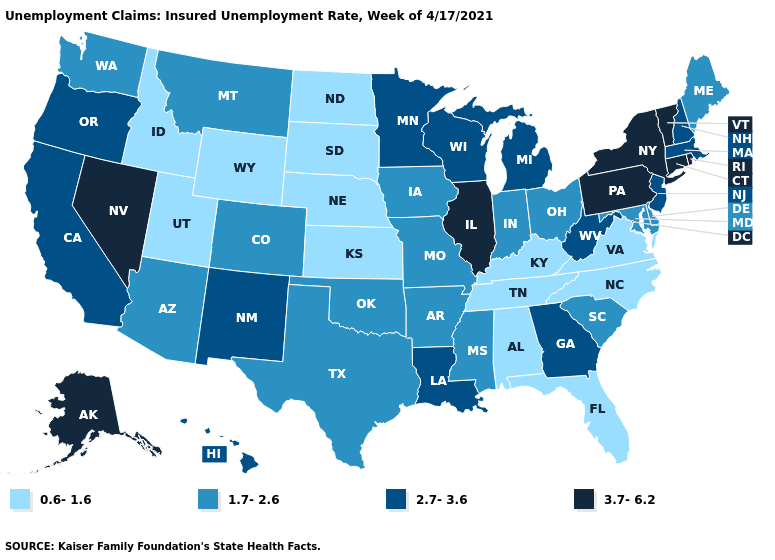Among the states that border Wisconsin , does Minnesota have the lowest value?
Be succinct. No. Name the states that have a value in the range 3.7-6.2?
Quick response, please. Alaska, Connecticut, Illinois, Nevada, New York, Pennsylvania, Rhode Island, Vermont. Name the states that have a value in the range 2.7-3.6?
Answer briefly. California, Georgia, Hawaii, Louisiana, Massachusetts, Michigan, Minnesota, New Hampshire, New Jersey, New Mexico, Oregon, West Virginia, Wisconsin. What is the value of West Virginia?
Short answer required. 2.7-3.6. What is the value of California?
Give a very brief answer. 2.7-3.6. Does South Dakota have a lower value than Idaho?
Quick response, please. No. What is the value of Maine?
Write a very short answer. 1.7-2.6. Name the states that have a value in the range 0.6-1.6?
Give a very brief answer. Alabama, Florida, Idaho, Kansas, Kentucky, Nebraska, North Carolina, North Dakota, South Dakota, Tennessee, Utah, Virginia, Wyoming. How many symbols are there in the legend?
Quick response, please. 4. Does the map have missing data?
Concise answer only. No. What is the highest value in the USA?
Write a very short answer. 3.7-6.2. How many symbols are there in the legend?
Answer briefly. 4. Which states have the highest value in the USA?
Short answer required. Alaska, Connecticut, Illinois, Nevada, New York, Pennsylvania, Rhode Island, Vermont. Does New Jersey have the lowest value in the USA?
Answer briefly. No. What is the value of Montana?
Be succinct. 1.7-2.6. 